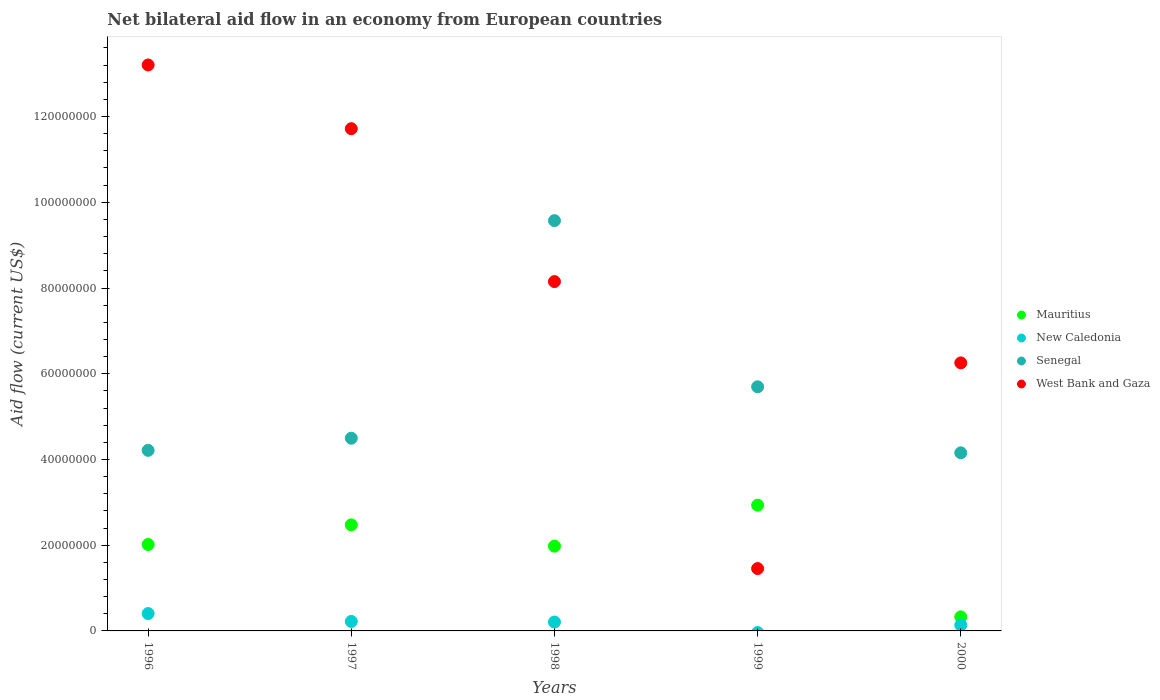How many different coloured dotlines are there?
Your answer should be compact. 4. Is the number of dotlines equal to the number of legend labels?
Your answer should be very brief. No. What is the net bilateral aid flow in Senegal in 1997?
Your answer should be compact. 4.50e+07. Across all years, what is the maximum net bilateral aid flow in West Bank and Gaza?
Ensure brevity in your answer.  1.32e+08. Across all years, what is the minimum net bilateral aid flow in Mauritius?
Provide a short and direct response. 3.28e+06. In which year was the net bilateral aid flow in West Bank and Gaza maximum?
Make the answer very short. 1996. What is the total net bilateral aid flow in West Bank and Gaza in the graph?
Give a very brief answer. 4.08e+08. What is the difference between the net bilateral aid flow in West Bank and Gaza in 1999 and that in 2000?
Offer a terse response. -4.80e+07. What is the difference between the net bilateral aid flow in West Bank and Gaza in 1999 and the net bilateral aid flow in New Caledonia in 1996?
Provide a short and direct response. 1.05e+07. What is the average net bilateral aid flow in Mauritius per year?
Provide a succinct answer. 1.95e+07. In the year 1998, what is the difference between the net bilateral aid flow in Senegal and net bilateral aid flow in New Caledonia?
Offer a very short reply. 9.36e+07. In how many years, is the net bilateral aid flow in Mauritius greater than 92000000 US$?
Your answer should be compact. 0. What is the ratio of the net bilateral aid flow in Mauritius in 1998 to that in 2000?
Provide a succinct answer. 6.03. Is the difference between the net bilateral aid flow in Senegal in 1996 and 1997 greater than the difference between the net bilateral aid flow in New Caledonia in 1996 and 1997?
Offer a terse response. No. What is the difference between the highest and the second highest net bilateral aid flow in New Caledonia?
Give a very brief answer. 1.84e+06. What is the difference between the highest and the lowest net bilateral aid flow in West Bank and Gaza?
Offer a very short reply. 1.17e+08. In how many years, is the net bilateral aid flow in New Caledonia greater than the average net bilateral aid flow in New Caledonia taken over all years?
Keep it short and to the point. 3. Is the sum of the net bilateral aid flow in Senegal in 1998 and 1999 greater than the maximum net bilateral aid flow in New Caledonia across all years?
Provide a short and direct response. Yes. Is it the case that in every year, the sum of the net bilateral aid flow in Senegal and net bilateral aid flow in Mauritius  is greater than the sum of net bilateral aid flow in New Caledonia and net bilateral aid flow in West Bank and Gaza?
Provide a succinct answer. Yes. Is the net bilateral aid flow in New Caledonia strictly less than the net bilateral aid flow in Senegal over the years?
Make the answer very short. Yes. How many years are there in the graph?
Your answer should be very brief. 5. What is the difference between two consecutive major ticks on the Y-axis?
Your answer should be very brief. 2.00e+07. Are the values on the major ticks of Y-axis written in scientific E-notation?
Your answer should be compact. No. Does the graph contain any zero values?
Provide a short and direct response. Yes. Does the graph contain grids?
Give a very brief answer. No. Where does the legend appear in the graph?
Give a very brief answer. Center right. How many legend labels are there?
Give a very brief answer. 4. What is the title of the graph?
Offer a very short reply. Net bilateral aid flow in an economy from European countries. What is the label or title of the Y-axis?
Your answer should be very brief. Aid flow (current US$). What is the Aid flow (current US$) of Mauritius in 1996?
Your answer should be very brief. 2.02e+07. What is the Aid flow (current US$) of New Caledonia in 1996?
Your answer should be very brief. 4.05e+06. What is the Aid flow (current US$) of Senegal in 1996?
Your answer should be very brief. 4.21e+07. What is the Aid flow (current US$) in West Bank and Gaza in 1996?
Ensure brevity in your answer.  1.32e+08. What is the Aid flow (current US$) of Mauritius in 1997?
Keep it short and to the point. 2.47e+07. What is the Aid flow (current US$) in New Caledonia in 1997?
Ensure brevity in your answer.  2.21e+06. What is the Aid flow (current US$) of Senegal in 1997?
Give a very brief answer. 4.50e+07. What is the Aid flow (current US$) in West Bank and Gaza in 1997?
Give a very brief answer. 1.17e+08. What is the Aid flow (current US$) in Mauritius in 1998?
Ensure brevity in your answer.  1.98e+07. What is the Aid flow (current US$) in New Caledonia in 1998?
Your answer should be compact. 2.07e+06. What is the Aid flow (current US$) of Senegal in 1998?
Provide a short and direct response. 9.57e+07. What is the Aid flow (current US$) of West Bank and Gaza in 1998?
Ensure brevity in your answer.  8.15e+07. What is the Aid flow (current US$) of Mauritius in 1999?
Keep it short and to the point. 2.93e+07. What is the Aid flow (current US$) of Senegal in 1999?
Your response must be concise. 5.70e+07. What is the Aid flow (current US$) of West Bank and Gaza in 1999?
Offer a very short reply. 1.46e+07. What is the Aid flow (current US$) of Mauritius in 2000?
Offer a terse response. 3.28e+06. What is the Aid flow (current US$) of New Caledonia in 2000?
Your response must be concise. 1.36e+06. What is the Aid flow (current US$) in Senegal in 2000?
Your answer should be compact. 4.16e+07. What is the Aid flow (current US$) of West Bank and Gaza in 2000?
Offer a terse response. 6.25e+07. Across all years, what is the maximum Aid flow (current US$) of Mauritius?
Provide a succinct answer. 2.93e+07. Across all years, what is the maximum Aid flow (current US$) in New Caledonia?
Provide a short and direct response. 4.05e+06. Across all years, what is the maximum Aid flow (current US$) of Senegal?
Offer a terse response. 9.57e+07. Across all years, what is the maximum Aid flow (current US$) of West Bank and Gaza?
Keep it short and to the point. 1.32e+08. Across all years, what is the minimum Aid flow (current US$) in Mauritius?
Offer a terse response. 3.28e+06. Across all years, what is the minimum Aid flow (current US$) of New Caledonia?
Ensure brevity in your answer.  0. Across all years, what is the minimum Aid flow (current US$) of Senegal?
Provide a short and direct response. 4.16e+07. Across all years, what is the minimum Aid flow (current US$) of West Bank and Gaza?
Your answer should be compact. 1.46e+07. What is the total Aid flow (current US$) of Mauritius in the graph?
Keep it short and to the point. 9.73e+07. What is the total Aid flow (current US$) in New Caledonia in the graph?
Make the answer very short. 9.69e+06. What is the total Aid flow (current US$) in Senegal in the graph?
Provide a short and direct response. 2.81e+08. What is the total Aid flow (current US$) in West Bank and Gaza in the graph?
Your response must be concise. 4.08e+08. What is the difference between the Aid flow (current US$) of Mauritius in 1996 and that in 1997?
Provide a short and direct response. -4.58e+06. What is the difference between the Aid flow (current US$) in New Caledonia in 1996 and that in 1997?
Keep it short and to the point. 1.84e+06. What is the difference between the Aid flow (current US$) of Senegal in 1996 and that in 1997?
Provide a succinct answer. -2.83e+06. What is the difference between the Aid flow (current US$) in West Bank and Gaza in 1996 and that in 1997?
Provide a short and direct response. 1.49e+07. What is the difference between the Aid flow (current US$) in Mauritius in 1996 and that in 1998?
Offer a very short reply. 3.80e+05. What is the difference between the Aid flow (current US$) in New Caledonia in 1996 and that in 1998?
Give a very brief answer. 1.98e+06. What is the difference between the Aid flow (current US$) of Senegal in 1996 and that in 1998?
Keep it short and to the point. -5.36e+07. What is the difference between the Aid flow (current US$) in West Bank and Gaza in 1996 and that in 1998?
Give a very brief answer. 5.05e+07. What is the difference between the Aid flow (current US$) in Mauritius in 1996 and that in 1999?
Your answer should be very brief. -9.18e+06. What is the difference between the Aid flow (current US$) in Senegal in 1996 and that in 1999?
Provide a succinct answer. -1.48e+07. What is the difference between the Aid flow (current US$) of West Bank and Gaza in 1996 and that in 1999?
Ensure brevity in your answer.  1.17e+08. What is the difference between the Aid flow (current US$) in Mauritius in 1996 and that in 2000?
Your answer should be very brief. 1.69e+07. What is the difference between the Aid flow (current US$) in New Caledonia in 1996 and that in 2000?
Keep it short and to the point. 2.69e+06. What is the difference between the Aid flow (current US$) in Senegal in 1996 and that in 2000?
Your answer should be very brief. 5.80e+05. What is the difference between the Aid flow (current US$) in West Bank and Gaza in 1996 and that in 2000?
Provide a succinct answer. 6.95e+07. What is the difference between the Aid flow (current US$) in Mauritius in 1997 and that in 1998?
Your response must be concise. 4.96e+06. What is the difference between the Aid flow (current US$) of New Caledonia in 1997 and that in 1998?
Provide a succinct answer. 1.40e+05. What is the difference between the Aid flow (current US$) in Senegal in 1997 and that in 1998?
Your response must be concise. -5.08e+07. What is the difference between the Aid flow (current US$) in West Bank and Gaza in 1997 and that in 1998?
Provide a succinct answer. 3.57e+07. What is the difference between the Aid flow (current US$) of Mauritius in 1997 and that in 1999?
Your response must be concise. -4.60e+06. What is the difference between the Aid flow (current US$) of Senegal in 1997 and that in 1999?
Your answer should be very brief. -1.20e+07. What is the difference between the Aid flow (current US$) in West Bank and Gaza in 1997 and that in 1999?
Offer a very short reply. 1.03e+08. What is the difference between the Aid flow (current US$) of Mauritius in 1997 and that in 2000?
Offer a very short reply. 2.15e+07. What is the difference between the Aid flow (current US$) of New Caledonia in 1997 and that in 2000?
Provide a short and direct response. 8.50e+05. What is the difference between the Aid flow (current US$) in Senegal in 1997 and that in 2000?
Your answer should be compact. 3.41e+06. What is the difference between the Aid flow (current US$) in West Bank and Gaza in 1997 and that in 2000?
Give a very brief answer. 5.46e+07. What is the difference between the Aid flow (current US$) of Mauritius in 1998 and that in 1999?
Your answer should be compact. -9.56e+06. What is the difference between the Aid flow (current US$) of Senegal in 1998 and that in 1999?
Your answer should be compact. 3.88e+07. What is the difference between the Aid flow (current US$) of West Bank and Gaza in 1998 and that in 1999?
Offer a terse response. 6.70e+07. What is the difference between the Aid flow (current US$) in Mauritius in 1998 and that in 2000?
Your response must be concise. 1.65e+07. What is the difference between the Aid flow (current US$) in New Caledonia in 1998 and that in 2000?
Make the answer very short. 7.10e+05. What is the difference between the Aid flow (current US$) of Senegal in 1998 and that in 2000?
Give a very brief answer. 5.42e+07. What is the difference between the Aid flow (current US$) in West Bank and Gaza in 1998 and that in 2000?
Your response must be concise. 1.90e+07. What is the difference between the Aid flow (current US$) of Mauritius in 1999 and that in 2000?
Your answer should be compact. 2.61e+07. What is the difference between the Aid flow (current US$) in Senegal in 1999 and that in 2000?
Your response must be concise. 1.54e+07. What is the difference between the Aid flow (current US$) in West Bank and Gaza in 1999 and that in 2000?
Offer a terse response. -4.80e+07. What is the difference between the Aid flow (current US$) of Mauritius in 1996 and the Aid flow (current US$) of New Caledonia in 1997?
Offer a terse response. 1.80e+07. What is the difference between the Aid flow (current US$) of Mauritius in 1996 and the Aid flow (current US$) of Senegal in 1997?
Provide a short and direct response. -2.48e+07. What is the difference between the Aid flow (current US$) in Mauritius in 1996 and the Aid flow (current US$) in West Bank and Gaza in 1997?
Give a very brief answer. -9.70e+07. What is the difference between the Aid flow (current US$) in New Caledonia in 1996 and the Aid flow (current US$) in Senegal in 1997?
Make the answer very short. -4.09e+07. What is the difference between the Aid flow (current US$) in New Caledonia in 1996 and the Aid flow (current US$) in West Bank and Gaza in 1997?
Give a very brief answer. -1.13e+08. What is the difference between the Aid flow (current US$) of Senegal in 1996 and the Aid flow (current US$) of West Bank and Gaza in 1997?
Your response must be concise. -7.50e+07. What is the difference between the Aid flow (current US$) in Mauritius in 1996 and the Aid flow (current US$) in New Caledonia in 1998?
Your answer should be very brief. 1.81e+07. What is the difference between the Aid flow (current US$) of Mauritius in 1996 and the Aid flow (current US$) of Senegal in 1998?
Give a very brief answer. -7.56e+07. What is the difference between the Aid flow (current US$) in Mauritius in 1996 and the Aid flow (current US$) in West Bank and Gaza in 1998?
Your answer should be very brief. -6.13e+07. What is the difference between the Aid flow (current US$) of New Caledonia in 1996 and the Aid flow (current US$) of Senegal in 1998?
Keep it short and to the point. -9.17e+07. What is the difference between the Aid flow (current US$) of New Caledonia in 1996 and the Aid flow (current US$) of West Bank and Gaza in 1998?
Keep it short and to the point. -7.74e+07. What is the difference between the Aid flow (current US$) of Senegal in 1996 and the Aid flow (current US$) of West Bank and Gaza in 1998?
Make the answer very short. -3.94e+07. What is the difference between the Aid flow (current US$) of Mauritius in 1996 and the Aid flow (current US$) of Senegal in 1999?
Offer a very short reply. -3.68e+07. What is the difference between the Aid flow (current US$) in Mauritius in 1996 and the Aid flow (current US$) in West Bank and Gaza in 1999?
Give a very brief answer. 5.61e+06. What is the difference between the Aid flow (current US$) of New Caledonia in 1996 and the Aid flow (current US$) of Senegal in 1999?
Keep it short and to the point. -5.29e+07. What is the difference between the Aid flow (current US$) of New Caledonia in 1996 and the Aid flow (current US$) of West Bank and Gaza in 1999?
Ensure brevity in your answer.  -1.05e+07. What is the difference between the Aid flow (current US$) in Senegal in 1996 and the Aid flow (current US$) in West Bank and Gaza in 1999?
Ensure brevity in your answer.  2.76e+07. What is the difference between the Aid flow (current US$) of Mauritius in 1996 and the Aid flow (current US$) of New Caledonia in 2000?
Your answer should be very brief. 1.88e+07. What is the difference between the Aid flow (current US$) in Mauritius in 1996 and the Aid flow (current US$) in Senegal in 2000?
Offer a terse response. -2.14e+07. What is the difference between the Aid flow (current US$) of Mauritius in 1996 and the Aid flow (current US$) of West Bank and Gaza in 2000?
Provide a succinct answer. -4.24e+07. What is the difference between the Aid flow (current US$) of New Caledonia in 1996 and the Aid flow (current US$) of Senegal in 2000?
Keep it short and to the point. -3.75e+07. What is the difference between the Aid flow (current US$) of New Caledonia in 1996 and the Aid flow (current US$) of West Bank and Gaza in 2000?
Provide a short and direct response. -5.85e+07. What is the difference between the Aid flow (current US$) in Senegal in 1996 and the Aid flow (current US$) in West Bank and Gaza in 2000?
Offer a very short reply. -2.04e+07. What is the difference between the Aid flow (current US$) of Mauritius in 1997 and the Aid flow (current US$) of New Caledonia in 1998?
Keep it short and to the point. 2.27e+07. What is the difference between the Aid flow (current US$) of Mauritius in 1997 and the Aid flow (current US$) of Senegal in 1998?
Provide a short and direct response. -7.10e+07. What is the difference between the Aid flow (current US$) of Mauritius in 1997 and the Aid flow (current US$) of West Bank and Gaza in 1998?
Make the answer very short. -5.68e+07. What is the difference between the Aid flow (current US$) of New Caledonia in 1997 and the Aid flow (current US$) of Senegal in 1998?
Your answer should be very brief. -9.35e+07. What is the difference between the Aid flow (current US$) of New Caledonia in 1997 and the Aid flow (current US$) of West Bank and Gaza in 1998?
Provide a short and direct response. -7.93e+07. What is the difference between the Aid flow (current US$) in Senegal in 1997 and the Aid flow (current US$) in West Bank and Gaza in 1998?
Offer a very short reply. -3.65e+07. What is the difference between the Aid flow (current US$) of Mauritius in 1997 and the Aid flow (current US$) of Senegal in 1999?
Your response must be concise. -3.22e+07. What is the difference between the Aid flow (current US$) of Mauritius in 1997 and the Aid flow (current US$) of West Bank and Gaza in 1999?
Ensure brevity in your answer.  1.02e+07. What is the difference between the Aid flow (current US$) in New Caledonia in 1997 and the Aid flow (current US$) in Senegal in 1999?
Your answer should be very brief. -5.47e+07. What is the difference between the Aid flow (current US$) of New Caledonia in 1997 and the Aid flow (current US$) of West Bank and Gaza in 1999?
Provide a short and direct response. -1.23e+07. What is the difference between the Aid flow (current US$) in Senegal in 1997 and the Aid flow (current US$) in West Bank and Gaza in 1999?
Provide a succinct answer. 3.04e+07. What is the difference between the Aid flow (current US$) of Mauritius in 1997 and the Aid flow (current US$) of New Caledonia in 2000?
Ensure brevity in your answer.  2.34e+07. What is the difference between the Aid flow (current US$) of Mauritius in 1997 and the Aid flow (current US$) of Senegal in 2000?
Your response must be concise. -1.68e+07. What is the difference between the Aid flow (current US$) in Mauritius in 1997 and the Aid flow (current US$) in West Bank and Gaza in 2000?
Your answer should be compact. -3.78e+07. What is the difference between the Aid flow (current US$) in New Caledonia in 1997 and the Aid flow (current US$) in Senegal in 2000?
Offer a terse response. -3.93e+07. What is the difference between the Aid flow (current US$) in New Caledonia in 1997 and the Aid flow (current US$) in West Bank and Gaza in 2000?
Provide a short and direct response. -6.03e+07. What is the difference between the Aid flow (current US$) in Senegal in 1997 and the Aid flow (current US$) in West Bank and Gaza in 2000?
Give a very brief answer. -1.76e+07. What is the difference between the Aid flow (current US$) in Mauritius in 1998 and the Aid flow (current US$) in Senegal in 1999?
Ensure brevity in your answer.  -3.72e+07. What is the difference between the Aid flow (current US$) of Mauritius in 1998 and the Aid flow (current US$) of West Bank and Gaza in 1999?
Ensure brevity in your answer.  5.23e+06. What is the difference between the Aid flow (current US$) of New Caledonia in 1998 and the Aid flow (current US$) of Senegal in 1999?
Provide a short and direct response. -5.49e+07. What is the difference between the Aid flow (current US$) of New Caledonia in 1998 and the Aid flow (current US$) of West Bank and Gaza in 1999?
Provide a succinct answer. -1.25e+07. What is the difference between the Aid flow (current US$) in Senegal in 1998 and the Aid flow (current US$) in West Bank and Gaza in 1999?
Your answer should be very brief. 8.12e+07. What is the difference between the Aid flow (current US$) in Mauritius in 1998 and the Aid flow (current US$) in New Caledonia in 2000?
Your response must be concise. 1.84e+07. What is the difference between the Aid flow (current US$) in Mauritius in 1998 and the Aid flow (current US$) in Senegal in 2000?
Make the answer very short. -2.18e+07. What is the difference between the Aid flow (current US$) of Mauritius in 1998 and the Aid flow (current US$) of West Bank and Gaza in 2000?
Offer a very short reply. -4.28e+07. What is the difference between the Aid flow (current US$) in New Caledonia in 1998 and the Aid flow (current US$) in Senegal in 2000?
Your response must be concise. -3.95e+07. What is the difference between the Aid flow (current US$) of New Caledonia in 1998 and the Aid flow (current US$) of West Bank and Gaza in 2000?
Make the answer very short. -6.05e+07. What is the difference between the Aid flow (current US$) of Senegal in 1998 and the Aid flow (current US$) of West Bank and Gaza in 2000?
Your response must be concise. 3.32e+07. What is the difference between the Aid flow (current US$) of Mauritius in 1999 and the Aid flow (current US$) of New Caledonia in 2000?
Provide a short and direct response. 2.80e+07. What is the difference between the Aid flow (current US$) in Mauritius in 1999 and the Aid flow (current US$) in Senegal in 2000?
Your response must be concise. -1.22e+07. What is the difference between the Aid flow (current US$) in Mauritius in 1999 and the Aid flow (current US$) in West Bank and Gaza in 2000?
Offer a very short reply. -3.32e+07. What is the difference between the Aid flow (current US$) in Senegal in 1999 and the Aid flow (current US$) in West Bank and Gaza in 2000?
Provide a succinct answer. -5.58e+06. What is the average Aid flow (current US$) of Mauritius per year?
Provide a short and direct response. 1.95e+07. What is the average Aid flow (current US$) in New Caledonia per year?
Give a very brief answer. 1.94e+06. What is the average Aid flow (current US$) of Senegal per year?
Your answer should be compact. 5.63e+07. What is the average Aid flow (current US$) of West Bank and Gaza per year?
Your answer should be compact. 8.16e+07. In the year 1996, what is the difference between the Aid flow (current US$) of Mauritius and Aid flow (current US$) of New Caledonia?
Give a very brief answer. 1.61e+07. In the year 1996, what is the difference between the Aid flow (current US$) in Mauritius and Aid flow (current US$) in Senegal?
Make the answer very short. -2.20e+07. In the year 1996, what is the difference between the Aid flow (current US$) in Mauritius and Aid flow (current US$) in West Bank and Gaza?
Provide a succinct answer. -1.12e+08. In the year 1996, what is the difference between the Aid flow (current US$) in New Caledonia and Aid flow (current US$) in Senegal?
Keep it short and to the point. -3.81e+07. In the year 1996, what is the difference between the Aid flow (current US$) in New Caledonia and Aid flow (current US$) in West Bank and Gaza?
Offer a very short reply. -1.28e+08. In the year 1996, what is the difference between the Aid flow (current US$) in Senegal and Aid flow (current US$) in West Bank and Gaza?
Your answer should be very brief. -8.99e+07. In the year 1997, what is the difference between the Aid flow (current US$) of Mauritius and Aid flow (current US$) of New Caledonia?
Make the answer very short. 2.25e+07. In the year 1997, what is the difference between the Aid flow (current US$) of Mauritius and Aid flow (current US$) of Senegal?
Provide a short and direct response. -2.02e+07. In the year 1997, what is the difference between the Aid flow (current US$) of Mauritius and Aid flow (current US$) of West Bank and Gaza?
Your answer should be compact. -9.24e+07. In the year 1997, what is the difference between the Aid flow (current US$) of New Caledonia and Aid flow (current US$) of Senegal?
Provide a succinct answer. -4.28e+07. In the year 1997, what is the difference between the Aid flow (current US$) in New Caledonia and Aid flow (current US$) in West Bank and Gaza?
Ensure brevity in your answer.  -1.15e+08. In the year 1997, what is the difference between the Aid flow (current US$) in Senegal and Aid flow (current US$) in West Bank and Gaza?
Ensure brevity in your answer.  -7.22e+07. In the year 1998, what is the difference between the Aid flow (current US$) of Mauritius and Aid flow (current US$) of New Caledonia?
Offer a very short reply. 1.77e+07. In the year 1998, what is the difference between the Aid flow (current US$) in Mauritius and Aid flow (current US$) in Senegal?
Ensure brevity in your answer.  -7.59e+07. In the year 1998, what is the difference between the Aid flow (current US$) of Mauritius and Aid flow (current US$) of West Bank and Gaza?
Give a very brief answer. -6.17e+07. In the year 1998, what is the difference between the Aid flow (current US$) of New Caledonia and Aid flow (current US$) of Senegal?
Offer a terse response. -9.36e+07. In the year 1998, what is the difference between the Aid flow (current US$) of New Caledonia and Aid flow (current US$) of West Bank and Gaza?
Offer a very short reply. -7.94e+07. In the year 1998, what is the difference between the Aid flow (current US$) of Senegal and Aid flow (current US$) of West Bank and Gaza?
Give a very brief answer. 1.42e+07. In the year 1999, what is the difference between the Aid flow (current US$) in Mauritius and Aid flow (current US$) in Senegal?
Make the answer very short. -2.76e+07. In the year 1999, what is the difference between the Aid flow (current US$) of Mauritius and Aid flow (current US$) of West Bank and Gaza?
Offer a terse response. 1.48e+07. In the year 1999, what is the difference between the Aid flow (current US$) in Senegal and Aid flow (current US$) in West Bank and Gaza?
Provide a short and direct response. 4.24e+07. In the year 2000, what is the difference between the Aid flow (current US$) in Mauritius and Aid flow (current US$) in New Caledonia?
Offer a very short reply. 1.92e+06. In the year 2000, what is the difference between the Aid flow (current US$) of Mauritius and Aid flow (current US$) of Senegal?
Make the answer very short. -3.83e+07. In the year 2000, what is the difference between the Aid flow (current US$) of Mauritius and Aid flow (current US$) of West Bank and Gaza?
Offer a terse response. -5.92e+07. In the year 2000, what is the difference between the Aid flow (current US$) of New Caledonia and Aid flow (current US$) of Senegal?
Make the answer very short. -4.02e+07. In the year 2000, what is the difference between the Aid flow (current US$) of New Caledonia and Aid flow (current US$) of West Bank and Gaza?
Offer a terse response. -6.12e+07. In the year 2000, what is the difference between the Aid flow (current US$) in Senegal and Aid flow (current US$) in West Bank and Gaza?
Offer a terse response. -2.10e+07. What is the ratio of the Aid flow (current US$) in Mauritius in 1996 to that in 1997?
Make the answer very short. 0.81. What is the ratio of the Aid flow (current US$) of New Caledonia in 1996 to that in 1997?
Provide a succinct answer. 1.83. What is the ratio of the Aid flow (current US$) in Senegal in 1996 to that in 1997?
Provide a succinct answer. 0.94. What is the ratio of the Aid flow (current US$) in West Bank and Gaza in 1996 to that in 1997?
Provide a succinct answer. 1.13. What is the ratio of the Aid flow (current US$) in Mauritius in 1996 to that in 1998?
Your answer should be compact. 1.02. What is the ratio of the Aid flow (current US$) of New Caledonia in 1996 to that in 1998?
Your answer should be compact. 1.96. What is the ratio of the Aid flow (current US$) of Senegal in 1996 to that in 1998?
Your response must be concise. 0.44. What is the ratio of the Aid flow (current US$) of West Bank and Gaza in 1996 to that in 1998?
Your answer should be very brief. 1.62. What is the ratio of the Aid flow (current US$) in Mauritius in 1996 to that in 1999?
Make the answer very short. 0.69. What is the ratio of the Aid flow (current US$) of Senegal in 1996 to that in 1999?
Keep it short and to the point. 0.74. What is the ratio of the Aid flow (current US$) in West Bank and Gaza in 1996 to that in 1999?
Your response must be concise. 9.07. What is the ratio of the Aid flow (current US$) of Mauritius in 1996 to that in 2000?
Ensure brevity in your answer.  6.15. What is the ratio of the Aid flow (current US$) in New Caledonia in 1996 to that in 2000?
Your answer should be compact. 2.98. What is the ratio of the Aid flow (current US$) in West Bank and Gaza in 1996 to that in 2000?
Keep it short and to the point. 2.11. What is the ratio of the Aid flow (current US$) of Mauritius in 1997 to that in 1998?
Keep it short and to the point. 1.25. What is the ratio of the Aid flow (current US$) in New Caledonia in 1997 to that in 1998?
Your response must be concise. 1.07. What is the ratio of the Aid flow (current US$) in Senegal in 1997 to that in 1998?
Keep it short and to the point. 0.47. What is the ratio of the Aid flow (current US$) in West Bank and Gaza in 1997 to that in 1998?
Ensure brevity in your answer.  1.44. What is the ratio of the Aid flow (current US$) of Mauritius in 1997 to that in 1999?
Your answer should be compact. 0.84. What is the ratio of the Aid flow (current US$) of Senegal in 1997 to that in 1999?
Ensure brevity in your answer.  0.79. What is the ratio of the Aid flow (current US$) in West Bank and Gaza in 1997 to that in 1999?
Keep it short and to the point. 8.05. What is the ratio of the Aid flow (current US$) of Mauritius in 1997 to that in 2000?
Provide a short and direct response. 7.54. What is the ratio of the Aid flow (current US$) of New Caledonia in 1997 to that in 2000?
Your answer should be compact. 1.62. What is the ratio of the Aid flow (current US$) of Senegal in 1997 to that in 2000?
Give a very brief answer. 1.08. What is the ratio of the Aid flow (current US$) of West Bank and Gaza in 1997 to that in 2000?
Make the answer very short. 1.87. What is the ratio of the Aid flow (current US$) in Mauritius in 1998 to that in 1999?
Provide a succinct answer. 0.67. What is the ratio of the Aid flow (current US$) of Senegal in 1998 to that in 1999?
Make the answer very short. 1.68. What is the ratio of the Aid flow (current US$) of West Bank and Gaza in 1998 to that in 1999?
Your answer should be very brief. 5.6. What is the ratio of the Aid flow (current US$) of Mauritius in 1998 to that in 2000?
Offer a terse response. 6.03. What is the ratio of the Aid flow (current US$) in New Caledonia in 1998 to that in 2000?
Provide a succinct answer. 1.52. What is the ratio of the Aid flow (current US$) of Senegal in 1998 to that in 2000?
Offer a terse response. 2.3. What is the ratio of the Aid flow (current US$) of West Bank and Gaza in 1998 to that in 2000?
Make the answer very short. 1.3. What is the ratio of the Aid flow (current US$) in Mauritius in 1999 to that in 2000?
Offer a very short reply. 8.95. What is the ratio of the Aid flow (current US$) in Senegal in 1999 to that in 2000?
Your answer should be very brief. 1.37. What is the ratio of the Aid flow (current US$) in West Bank and Gaza in 1999 to that in 2000?
Your answer should be compact. 0.23. What is the difference between the highest and the second highest Aid flow (current US$) in Mauritius?
Ensure brevity in your answer.  4.60e+06. What is the difference between the highest and the second highest Aid flow (current US$) of New Caledonia?
Keep it short and to the point. 1.84e+06. What is the difference between the highest and the second highest Aid flow (current US$) in Senegal?
Offer a very short reply. 3.88e+07. What is the difference between the highest and the second highest Aid flow (current US$) of West Bank and Gaza?
Make the answer very short. 1.49e+07. What is the difference between the highest and the lowest Aid flow (current US$) of Mauritius?
Give a very brief answer. 2.61e+07. What is the difference between the highest and the lowest Aid flow (current US$) in New Caledonia?
Ensure brevity in your answer.  4.05e+06. What is the difference between the highest and the lowest Aid flow (current US$) in Senegal?
Your answer should be compact. 5.42e+07. What is the difference between the highest and the lowest Aid flow (current US$) of West Bank and Gaza?
Provide a succinct answer. 1.17e+08. 